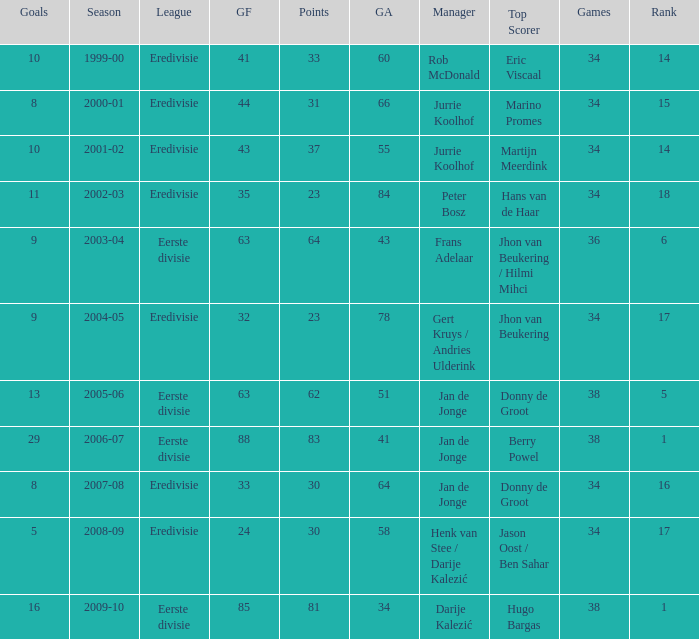How many goals were scored in the 2005-06 season? 13.0. 